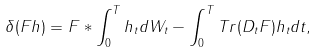Convert formula to latex. <formula><loc_0><loc_0><loc_500><loc_500>\delta ( F h ) = F * \int _ { 0 } ^ { T } { h _ { t } d W _ { t } } - \int _ { 0 } ^ { T } { T r ( D _ { t } F ) h _ { t } } d t ,</formula> 